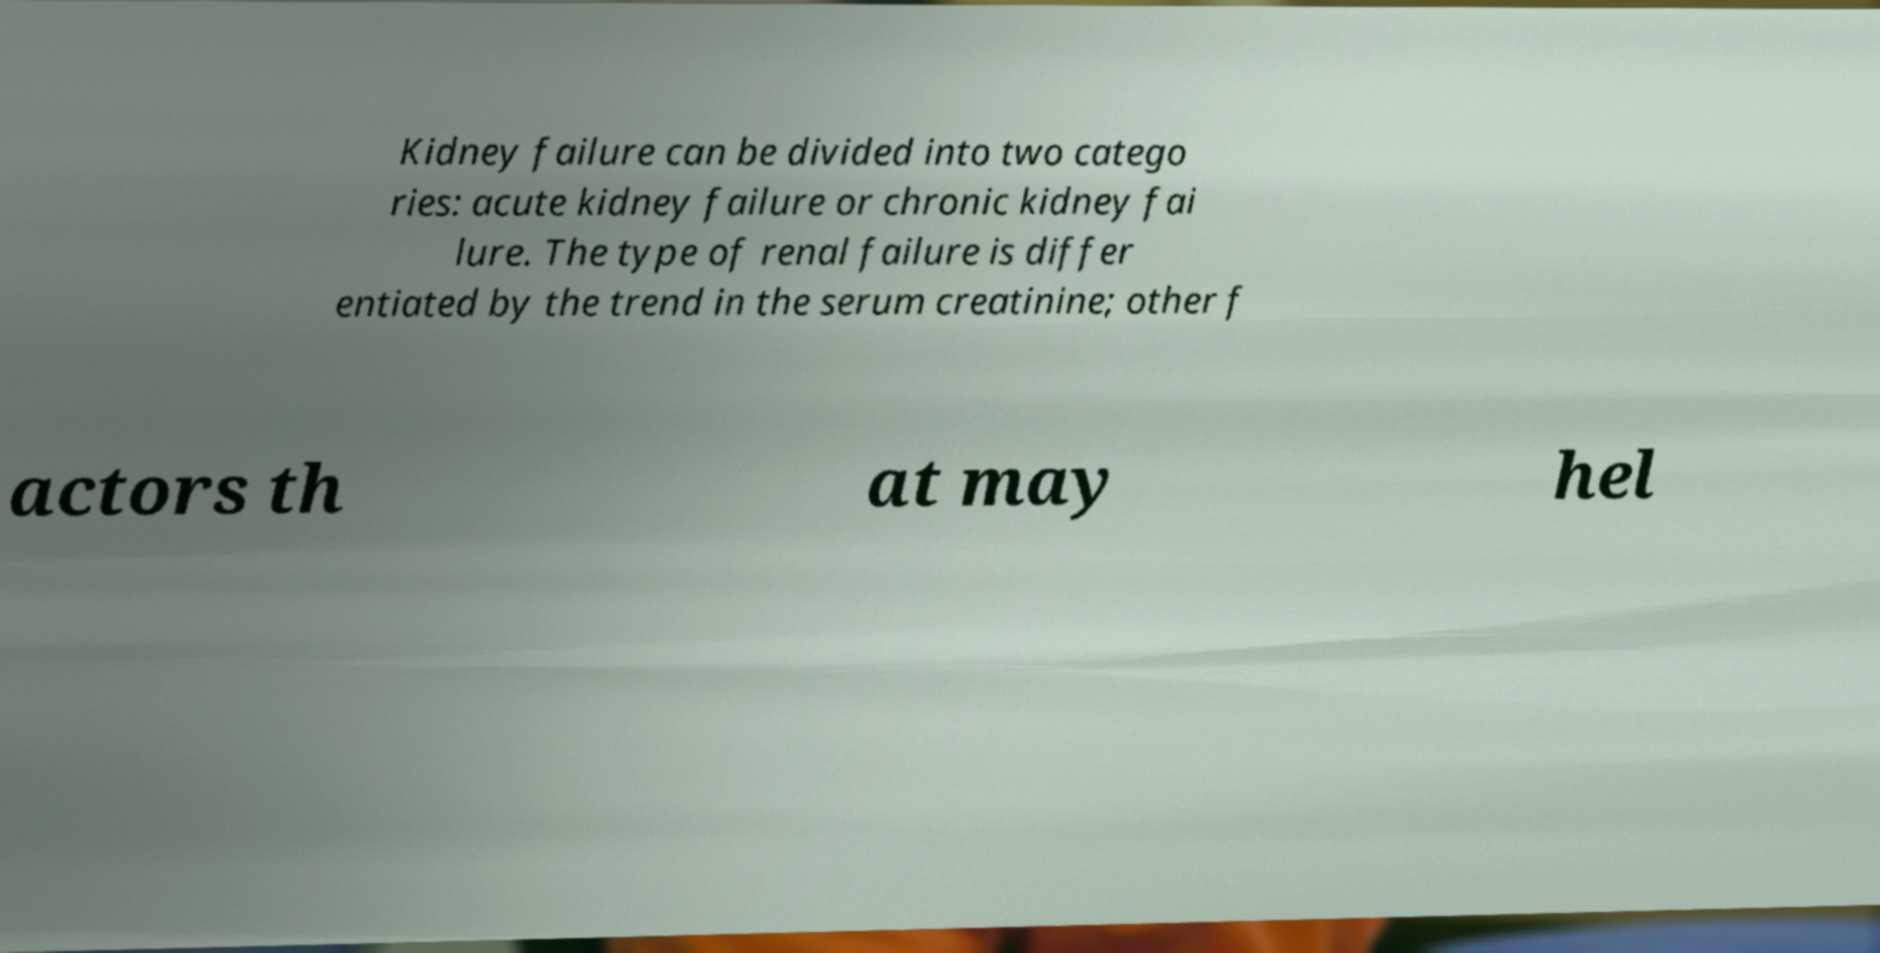Can you read and provide the text displayed in the image?This photo seems to have some interesting text. Can you extract and type it out for me? Kidney failure can be divided into two catego ries: acute kidney failure or chronic kidney fai lure. The type of renal failure is differ entiated by the trend in the serum creatinine; other f actors th at may hel 